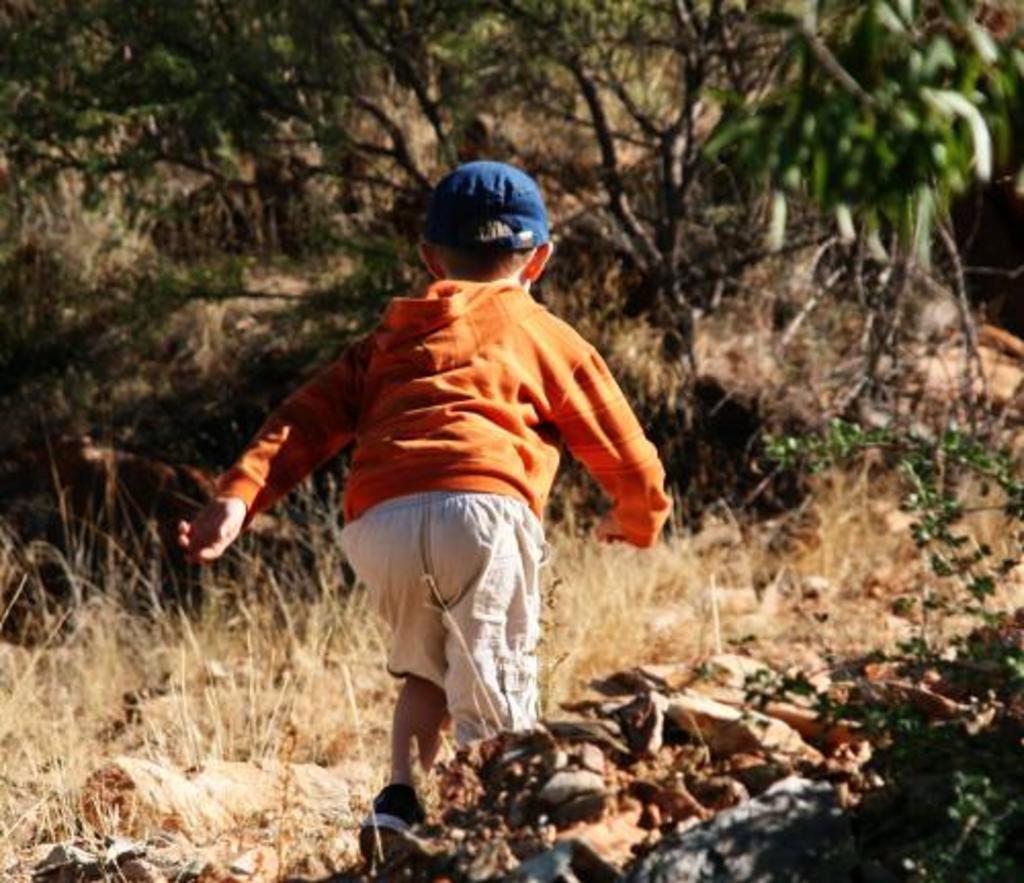In one or two sentences, can you explain what this image depicts? In this picture we can see a kid running, at the bottom there is grass and stones, we can see trees in the background, this kid wore a cap. 